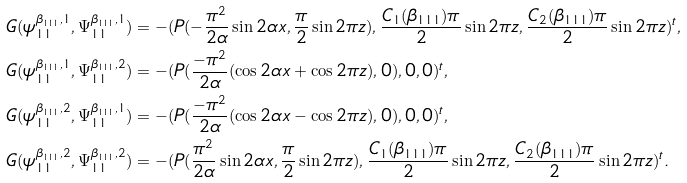<formula> <loc_0><loc_0><loc_500><loc_500>& G ( \psi _ { 1 1 } ^ { \beta _ { 1 1 1 } , 1 } , \Psi _ { 1 1 } ^ { \beta _ { 1 1 1 } , 1 } ) = - ( P ( - \frac { \pi ^ { 2 } } { 2 \alpha } \sin 2 \alpha x , \frac { \pi } { 2 } \sin 2 \pi z ) , \frac { C _ { 1 } ( \beta _ { 1 1 1 } ) \pi } { 2 } \sin 2 \pi z , \frac { C _ { 2 } ( \beta _ { 1 1 1 } ) \pi } { 2 } \sin 2 \pi z ) ^ { t } , \\ & G ( \psi _ { 1 1 } ^ { \beta _ { 1 1 1 } , 1 } , \Psi _ { 1 1 } ^ { \beta _ { 1 1 1 } , 2 } ) = - ( P ( \frac { - \pi ^ { 2 } } { 2 \alpha } ( \cos 2 \alpha x + \cos 2 \pi z ) , 0 ) , 0 , 0 ) ^ { t } , \\ & G ( \psi _ { 1 1 } ^ { \beta _ { 1 1 1 } , 2 } , \Psi _ { 1 1 } ^ { \beta _ { 1 1 1 } , 1 } ) = - ( P ( \frac { - \pi ^ { 2 } } { 2 \alpha } ( \cos 2 \alpha x - \cos 2 \pi z ) , 0 ) , 0 , 0 ) ^ { t } , \\ & G ( \psi _ { 1 1 } ^ { \beta _ { 1 1 1 } , 2 } , \Psi _ { 1 1 } ^ { \beta _ { 1 1 1 } , 2 } ) = - ( P ( \frac { \pi ^ { 2 } } { 2 \alpha } \sin 2 \alpha x , \frac { \pi } { 2 } \sin 2 \pi z ) , \frac { C _ { 1 } ( \beta _ { 1 1 1 } ) \pi } { 2 } \sin 2 \pi z , \frac { C _ { 2 } ( \beta _ { 1 1 1 } ) \pi } { 2 } \sin 2 \pi z ) ^ { t } .</formula> 